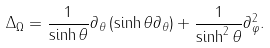<formula> <loc_0><loc_0><loc_500><loc_500>\Delta _ { \Omega } = \frac { 1 } { \sinh \theta } \partial _ { \theta } \left ( \sinh \theta \partial _ { \theta } \right ) + \frac { 1 } { \sinh ^ { 2 } \theta } \partial _ { \varphi } ^ { 2 } .</formula> 